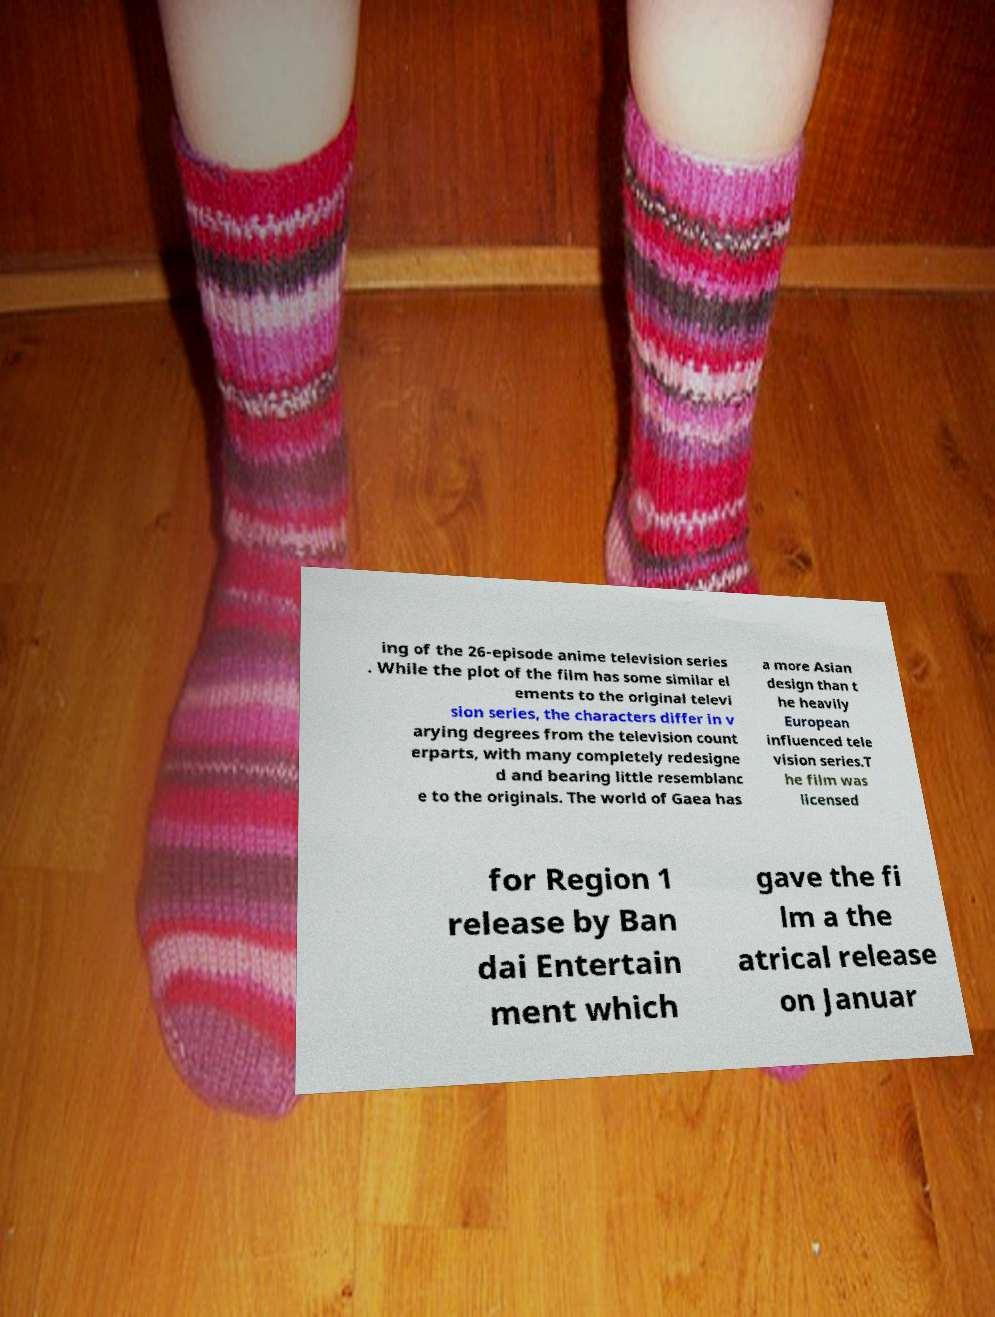Please identify and transcribe the text found in this image. ing of the 26-episode anime television series . While the plot of the film has some similar el ements to the original televi sion series, the characters differ in v arying degrees from the television count erparts, with many completely redesigne d and bearing little resemblanc e to the originals. The world of Gaea has a more Asian design than t he heavily European influenced tele vision series.T he film was licensed for Region 1 release by Ban dai Entertain ment which gave the fi lm a the atrical release on Januar 